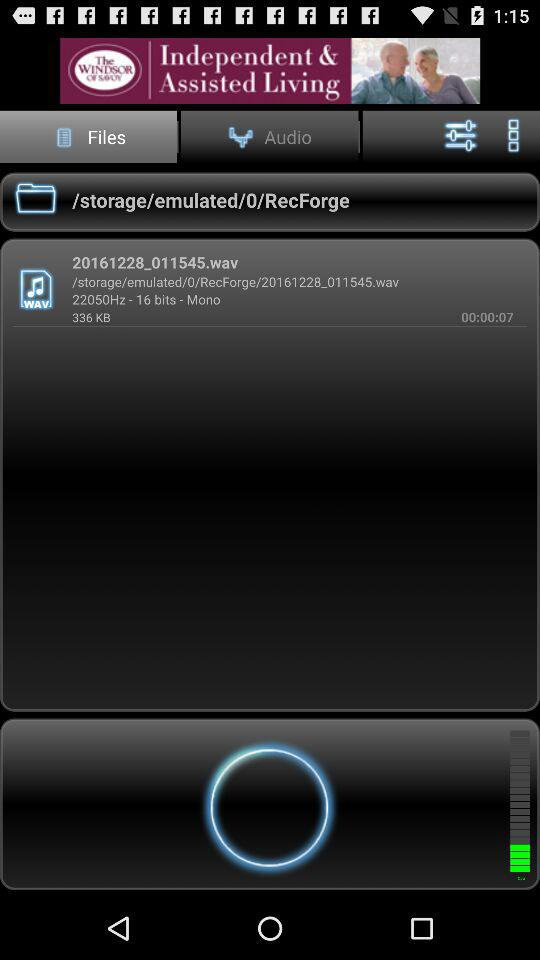Which tab is selected? The selected tab is "Files". 